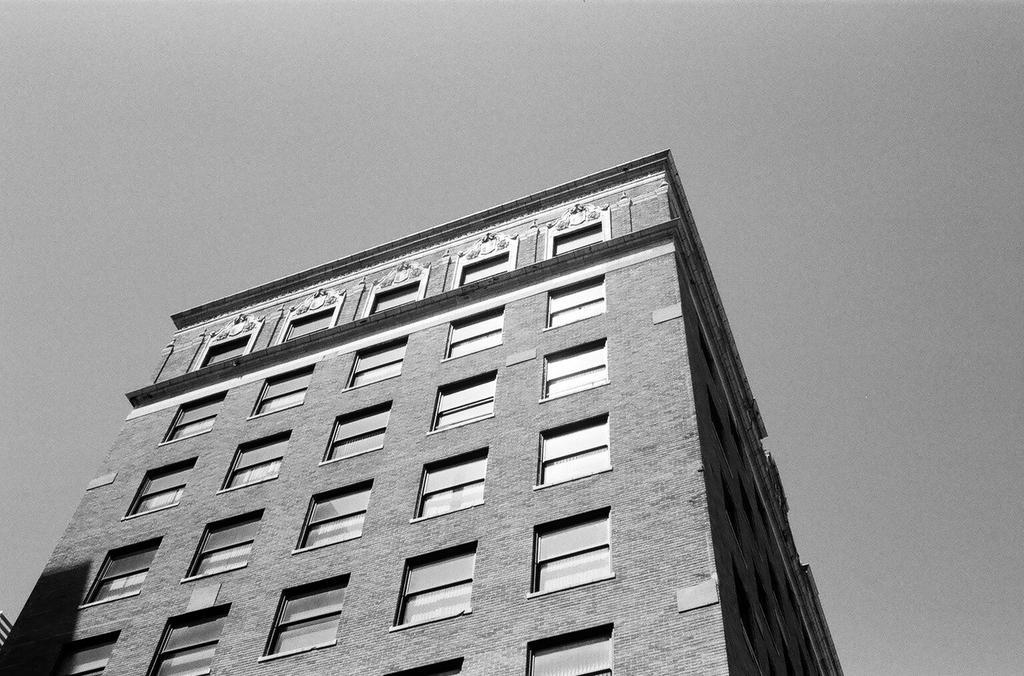Please provide a concise description of this image. This is a black and white picture. Here we can see a building. In the background there is sky. 